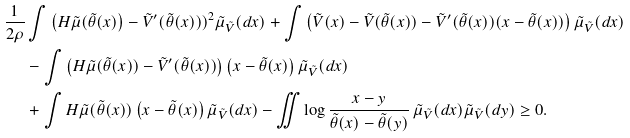<formula> <loc_0><loc_0><loc_500><loc_500>\frac { 1 } { 2 \rho } & \int \left ( H \tilde { \mu } ( \tilde { \theta } ( x ) \right ) - \tilde { V } ^ { \prime } ( \tilde { \theta } ( x ) ) ) ^ { 2 } \tilde { \mu } _ { \tilde { V } } ( d x ) + \int \left ( \tilde { V } ( x ) - \tilde { V } ( \tilde { \theta } ( x ) ) - \tilde { V } ^ { \prime } ( \tilde { \theta } ( x ) ) ( x - \tilde { \theta } ( x ) ) \right ) \tilde { \mu } _ { \tilde { V } } ( d x ) \\ & - \int \left ( H \tilde { \mu } ( \tilde { \theta } ( x ) ) - \tilde { V } ^ { \prime } ( \tilde { \theta } ( x ) ) \right ) \left ( x - \tilde { \theta } ( x ) \right ) \tilde { \mu } _ { \tilde { V } } ( d x ) \\ & + \int H \tilde { \mu } ( \tilde { \theta } ( x ) ) \left ( x - \tilde { \theta } ( x ) \right ) \tilde { \mu } _ { \tilde { V } } ( d x ) - \iint \log \frac { x - y } { \tilde { \theta } ( x ) - \tilde { \theta } ( y ) } \, \tilde { \mu } _ { \tilde { V } } ( d x ) \tilde { \mu } _ { \tilde { V } } ( d y ) \geq 0 .</formula> 